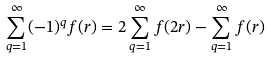Convert formula to latex. <formula><loc_0><loc_0><loc_500><loc_500>\sum _ { q = 1 } ^ { \infty } ( - 1 ) ^ { q } f ( r ) = 2 \sum _ { q = 1 } ^ { \infty } f ( 2 r ) - \sum _ { q = 1 } ^ { \infty } f ( r )</formula> 